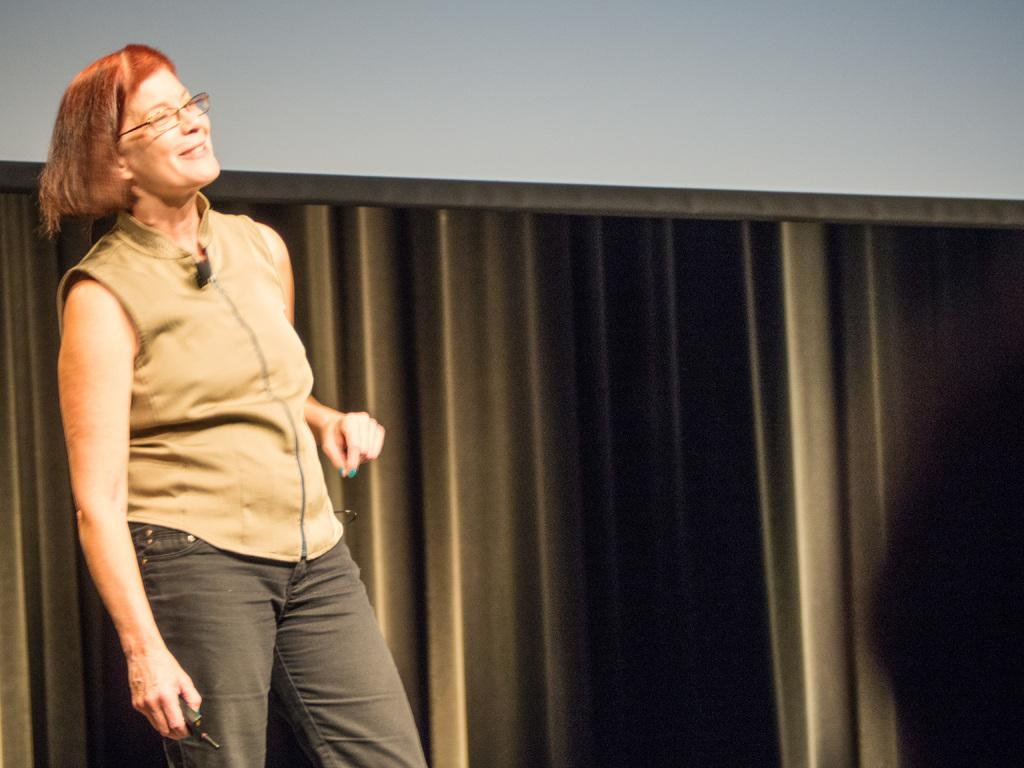What is the main subject of the image? The main subject of the image is a woman. What is the woman doing in the image? The woman is standing in the image. What is the woman's facial expression in the image? The woman is smiling in the image. What is the woman holding in her hand? The woman is holding a black color object in her hand. What accessories is the woman wearing in the image? The woman is wearing spectacles in the image. What type of clothing is the woman wearing in the image? The woman is wearing a top and trousers in the image. What is present in the background of the image? There is a curtain cloth hanging in the image. What type of fog can be seen in the image? There is no fog present in the image. Is the woman wearing a crown in the image? No, the woman is not wearing a crown in the image. What degree does the woman have, as indicated in the image? There is no indication of the woman's degree in the image. 